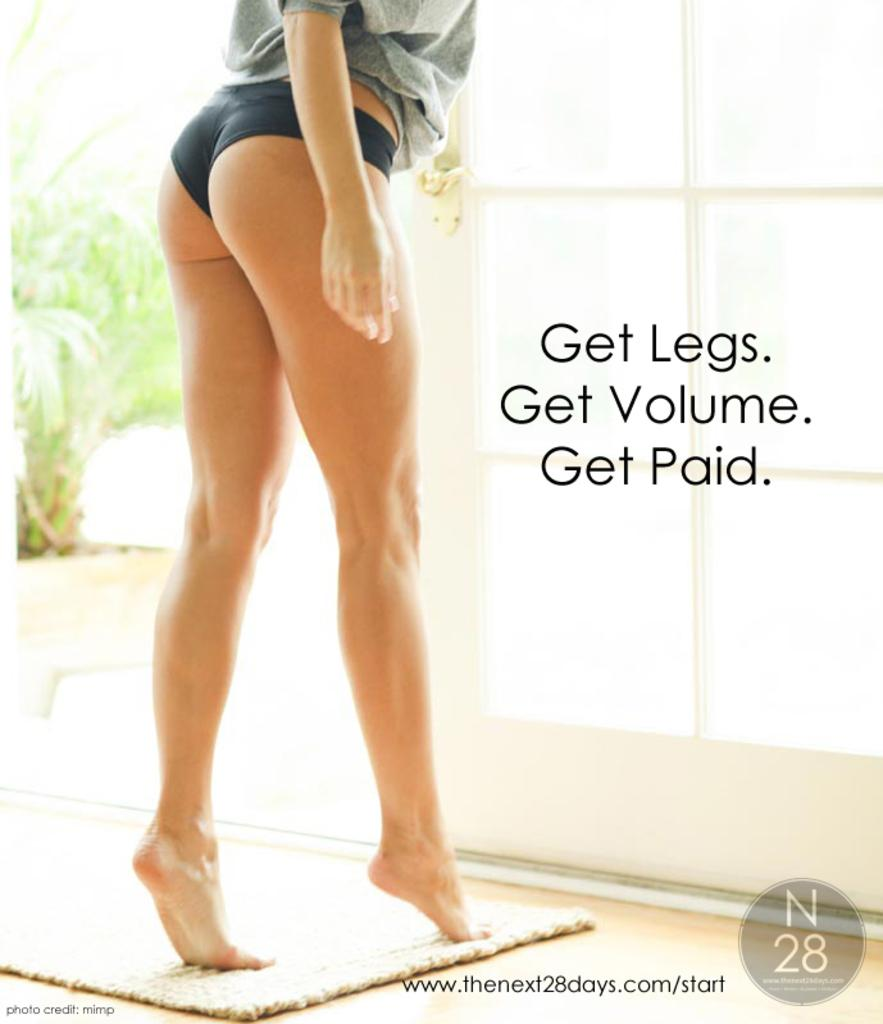What is the main subject of the image? There is a person standing in the image. What is the person wearing? The person is wearing a gray shirt. What can be seen in the background of the image? There are plants in the background of the image. What is the color of the plants? The plants are green in color. What else is visible in the image besides the person and plants? There is text or writing visible in the image. Is there a snail fighting with the person in the image? No, there is no snail or fighting depicted in the image. 